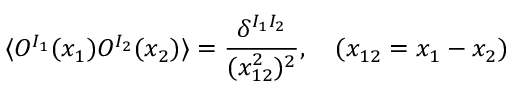Convert formula to latex. <formula><loc_0><loc_0><loc_500><loc_500>\langle O ^ { I _ { 1 } } ( x _ { 1 } ) O ^ { I _ { 2 } } ( x _ { 2 } ) \rangle = \frac { \delta ^ { I _ { 1 } I _ { 2 } } } { ( x _ { 1 2 } ^ { 2 } ) ^ { 2 } } , \quad ( x _ { 1 2 } = x _ { 1 } - x _ { 2 } )</formula> 